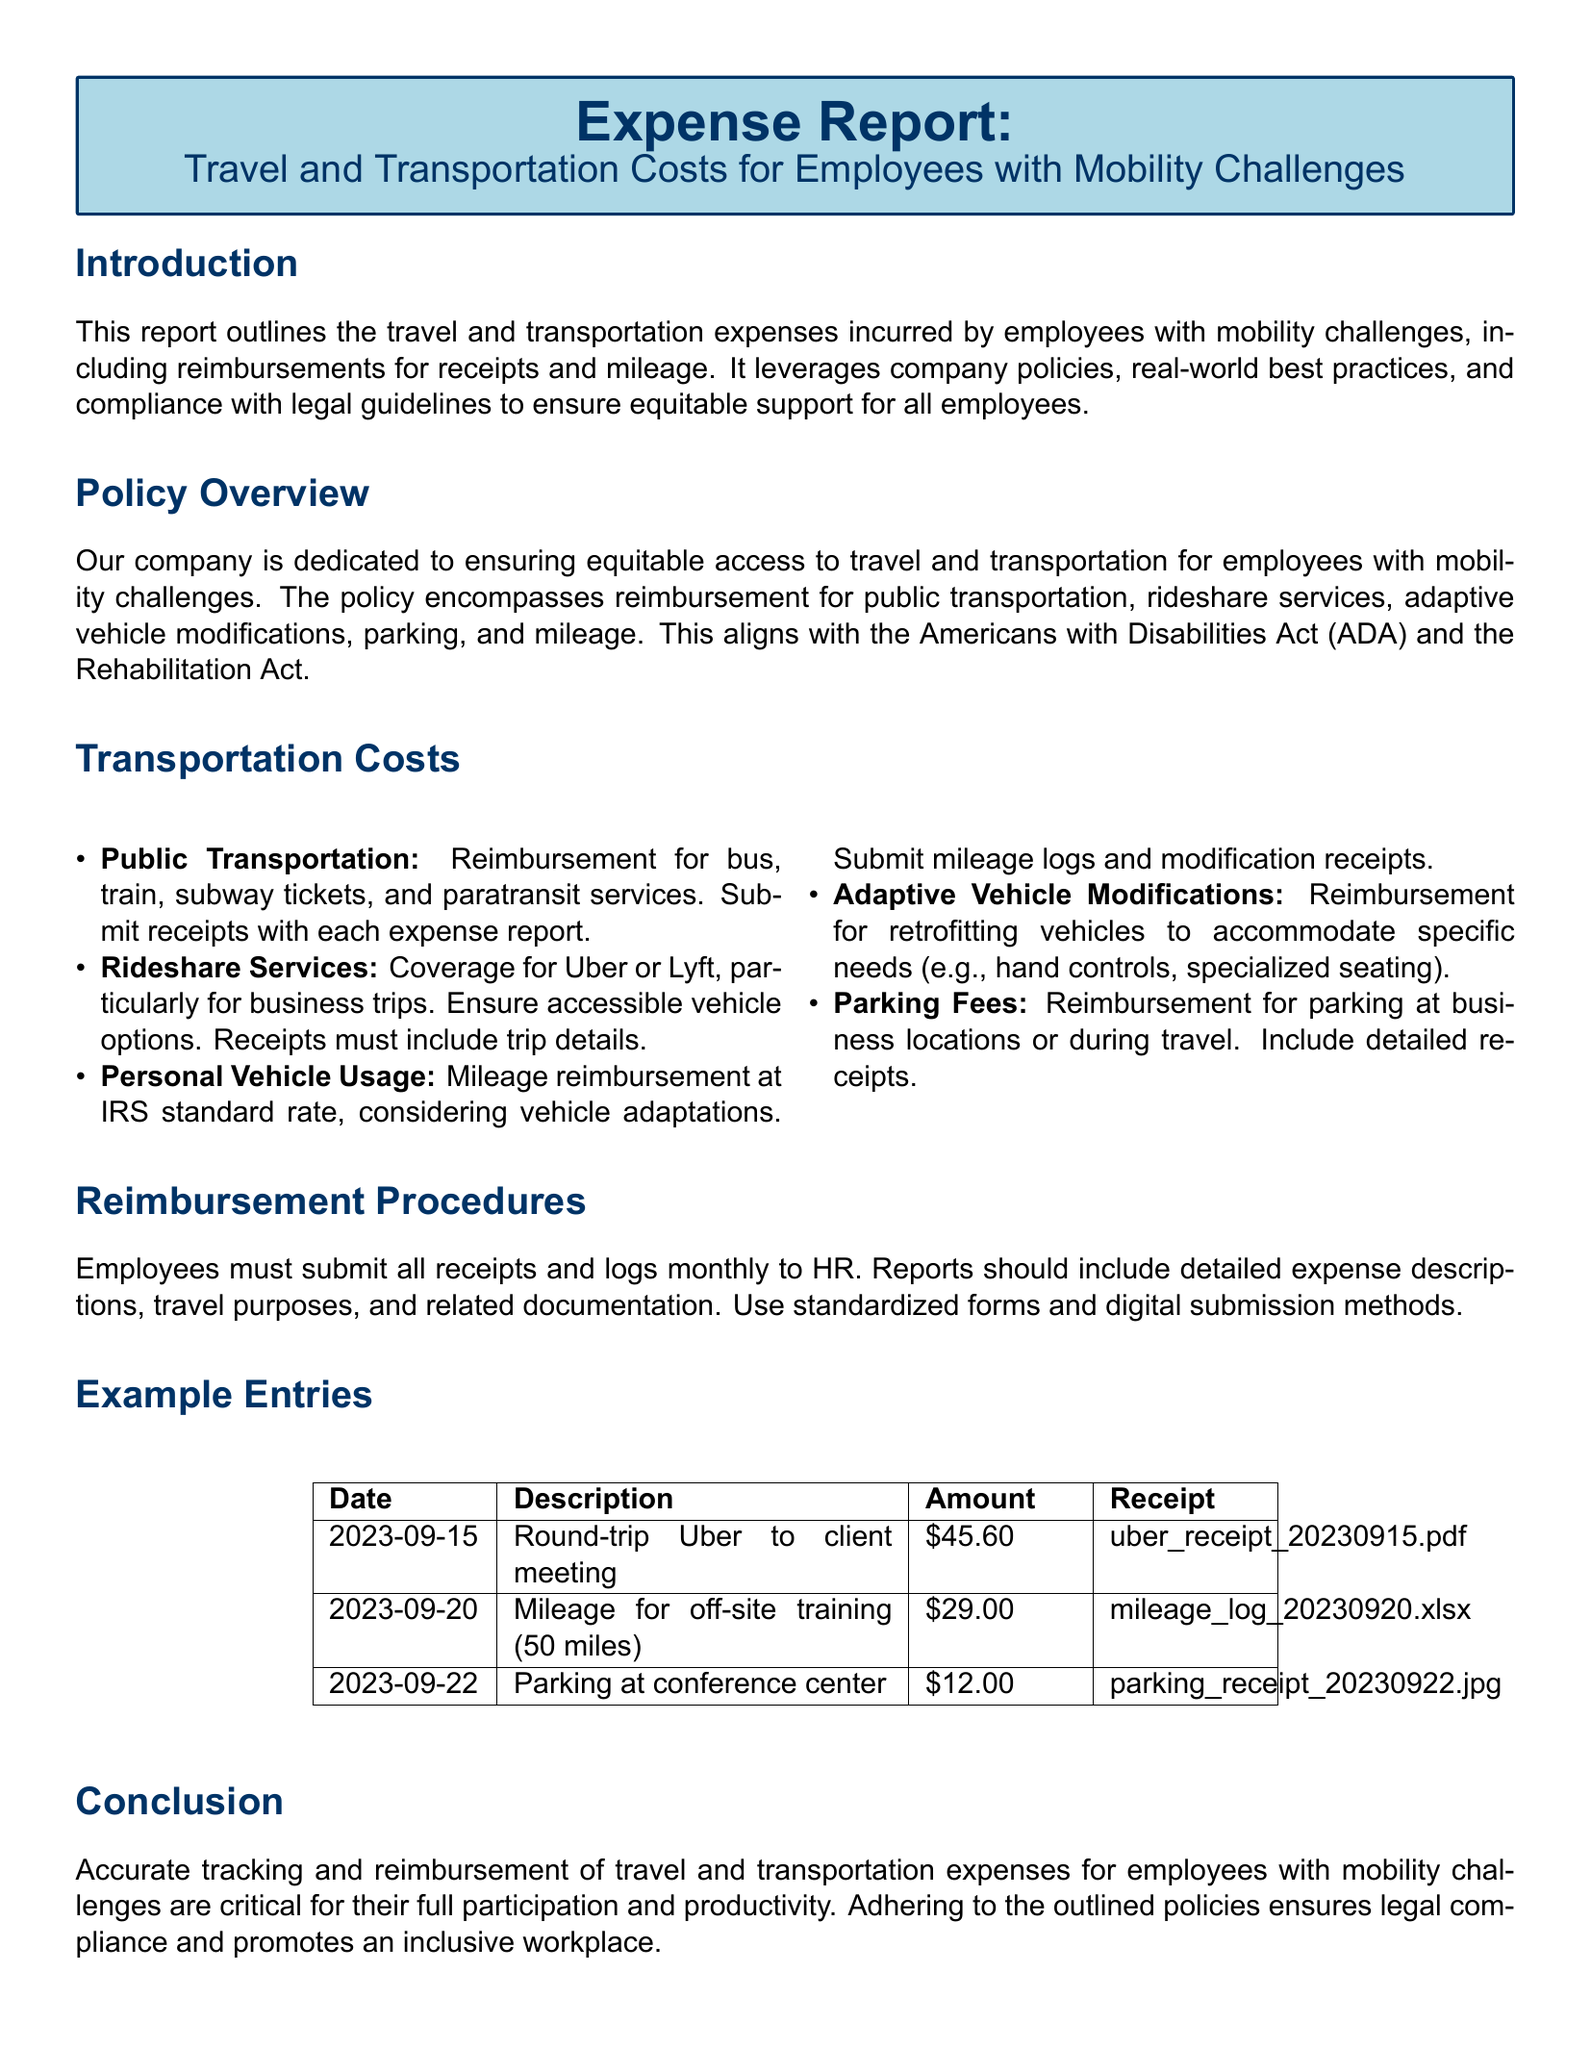What is the title of the report? The title of the report is prominently displayed at the beginning of the document, highlighting its focus on travel costs for employees with mobility challenges.
Answer: Expense Report: Travel and Transportation Costs for Employees with Mobility Challenges What must employees submit to HR for reimbursements? The document specifies the requirements for reimbursements, highlighting the need for receipts and logs.
Answer: Receipts and logs What is the IRS standard rate mentioned for mileage reimbursement? The report refers to the IRS standard rate but does not specify the exact rate within the document.
Answer: IRS standard rate Which services are covered for reimbursement under rideshare options? The report mentions specific rideshare services that are eligible for reimbursement, emphasizing accessibility.
Answer: Uber or Lyft How much was spent on parking at the conference center? The expense table provides the exact amount spent on parking, which is listed with details.
Answer: $12.00 What is required for reimbursement of adaptive vehicle modifications? The document outlines specific conditions about reimbursements but does not list detailed requirements in this context.
Answer: Retrofits for vehicles When must employees submit their expense reports? The report specifies a monthly submission timeline for expense reports to HR.
Answer: Monthly What is the reimbursement amount for the off-site training mileage? The expense table specifies the exact amount for the mileage incurred during off-site training.
Answer: $29.00 